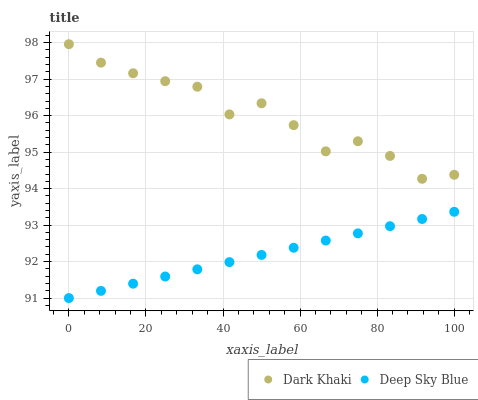Does Deep Sky Blue have the minimum area under the curve?
Answer yes or no. Yes. Does Dark Khaki have the maximum area under the curve?
Answer yes or no. Yes. Does Deep Sky Blue have the maximum area under the curve?
Answer yes or no. No. Is Deep Sky Blue the smoothest?
Answer yes or no. Yes. Is Dark Khaki the roughest?
Answer yes or no. Yes. Is Deep Sky Blue the roughest?
Answer yes or no. No. Does Deep Sky Blue have the lowest value?
Answer yes or no. Yes. Does Dark Khaki have the highest value?
Answer yes or no. Yes. Does Deep Sky Blue have the highest value?
Answer yes or no. No. Is Deep Sky Blue less than Dark Khaki?
Answer yes or no. Yes. Is Dark Khaki greater than Deep Sky Blue?
Answer yes or no. Yes. Does Deep Sky Blue intersect Dark Khaki?
Answer yes or no. No. 